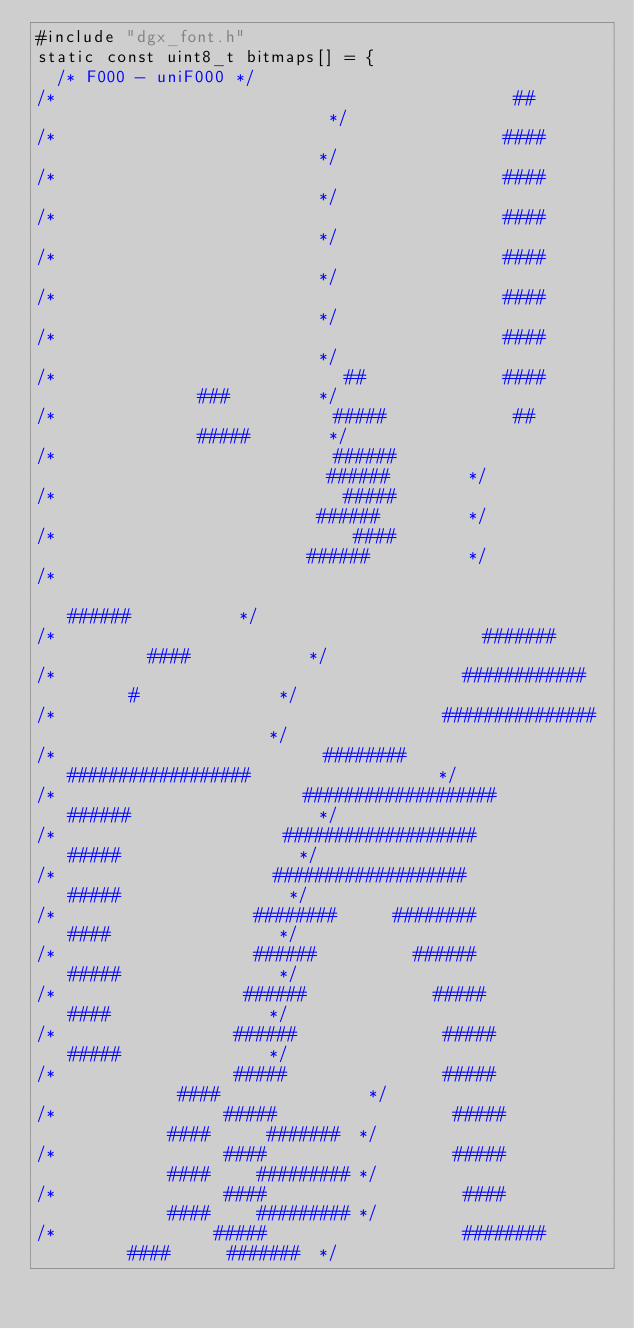<code> <loc_0><loc_0><loc_500><loc_500><_C_>#include "dgx_font.h"
static const uint8_t bitmaps[] = {
  /* F000 - uniF000 */
/*                                              ##                           */
/*                                             ####                          */
/*                                             ####                          */
/*                                             ####                          */
/*                                             ####                          */
/*                                             ####                          */
/*                                             ####                          */
/*                             ##              ####              ###         */
/*                            #####             ##              #####        */
/*                            ######                           ######        */
/*                             #####                          ######         */
/*                              ####                         ######          */
/*                                                          ######           */
/*                                           #######         ####            */
/*                                         ############       #              */
/*                                       ###############                     */
/*                           ########   ##################                   */
/*                         ###################      ######                   */
/*                       ###################          #####                  */
/*                      ###################            #####                 */
/*                    ########      ########            ####                 */
/*                    ######          ######            #####                */
/*                   ######             #####            ####                */
/*                  ######               #####           #####               */
/*                  #####                #####            ####               */
/*                 #####                  #####           ####      #######  */
/*                 ####                   #####           ####     ######### */
/*                 ####                    ####           ####     ######### */
/*                #####                    ########       ####      #######  */</code> 